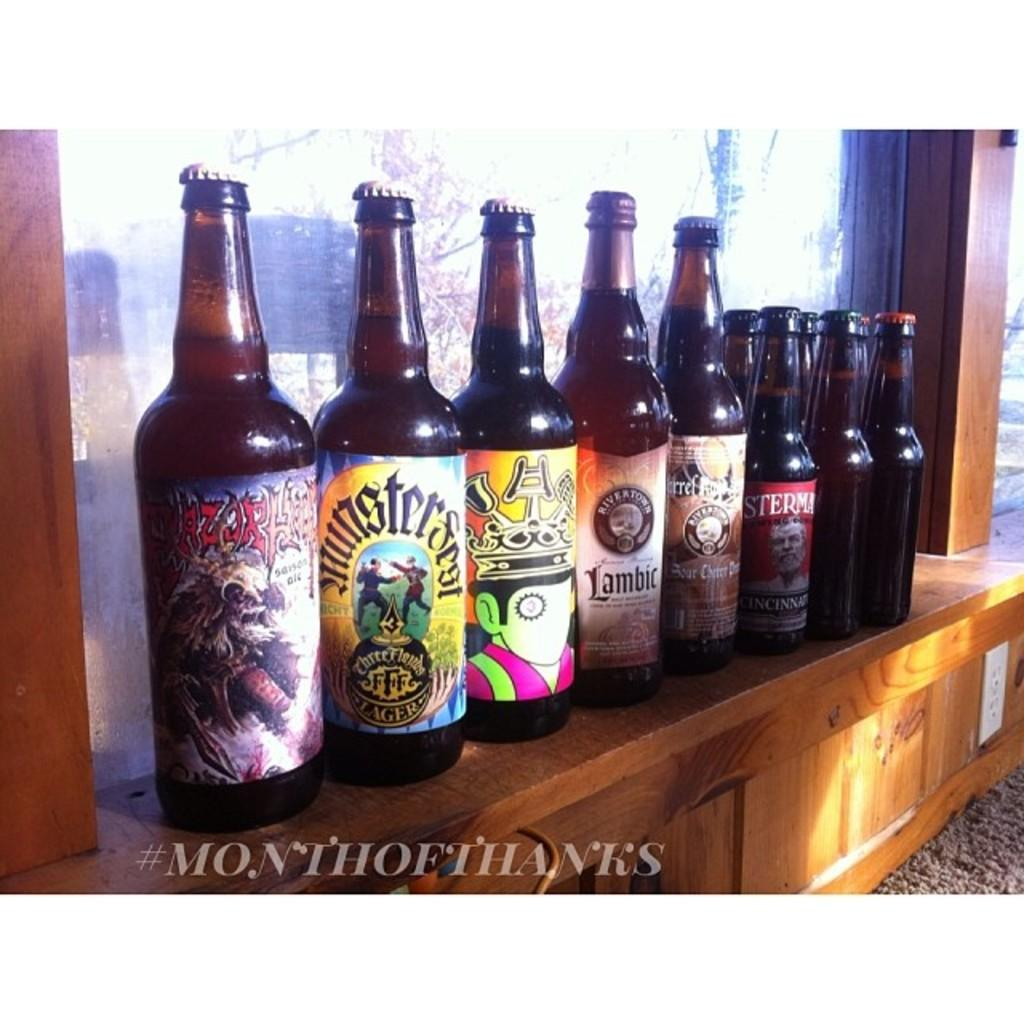What objects are present in the image? There are bottles in the image. How are the bottles arranged in the image? The bottles are arranged in a rack. What type of tent is visible in the image? There is no tent present in the image; it only features bottles arranged in a rack. 